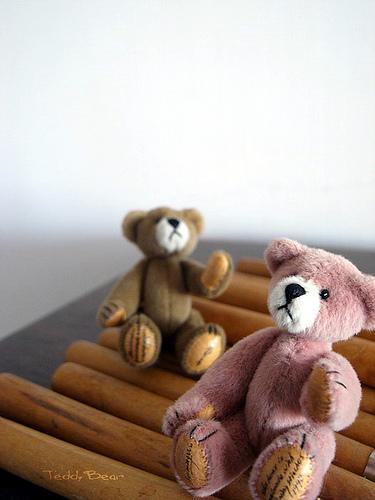What are the bears sitting on?
Concise answer only. Wood. Which color bear is closest to the camera?
Give a very brief answer. Pink. Are the bears the same color?
Keep it brief. No. 